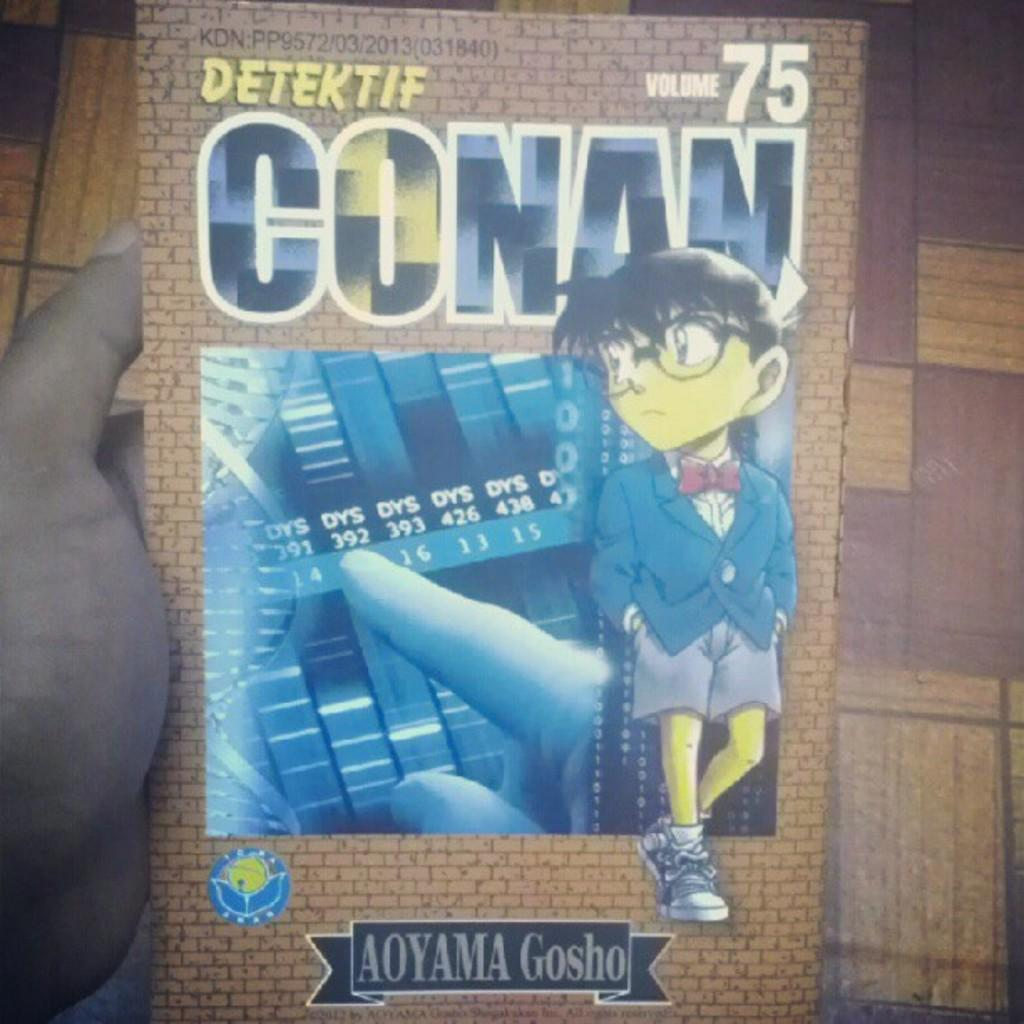<image>
Offer a succinct explanation of the picture presented. A comic book chronicles the adventures of Detective Conan. 